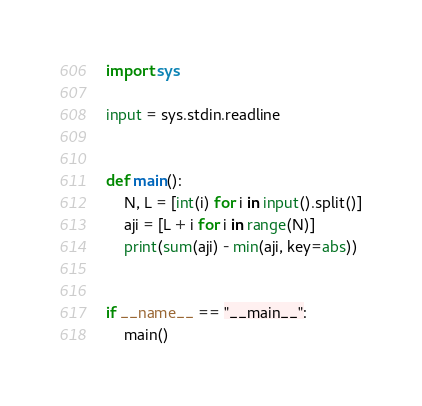Convert code to text. <code><loc_0><loc_0><loc_500><loc_500><_Python_>import sys

input = sys.stdin.readline


def main():
    N, L = [int(i) for i in input().split()]
    aji = [L + i for i in range(N)]
    print(sum(aji) - min(aji, key=abs))


if __name__ == "__main__":
    main()</code> 